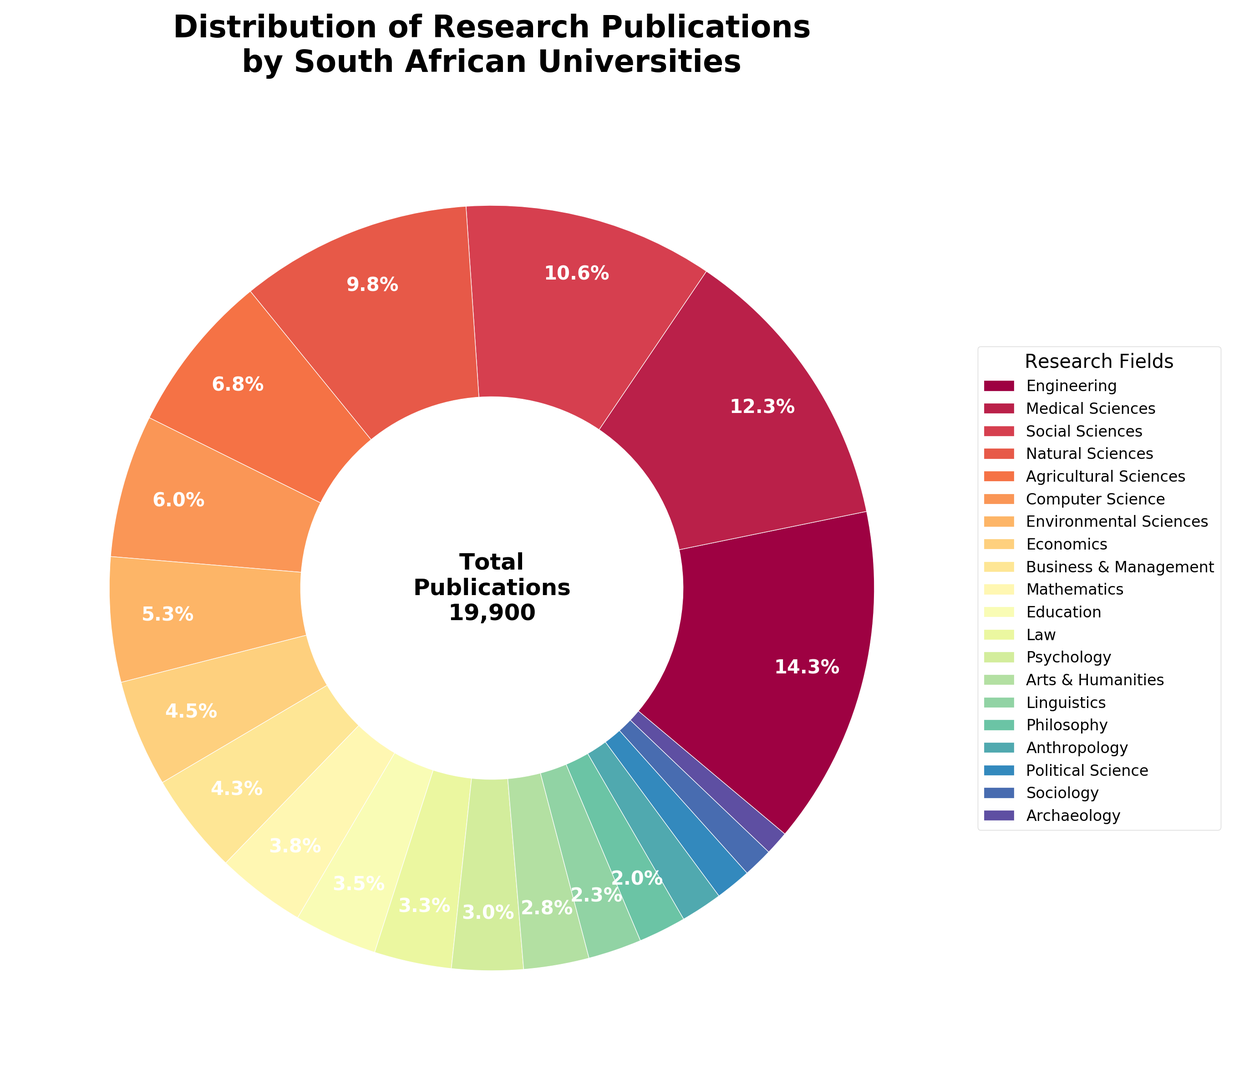Which field has the highest number of publications? To determine the field with the highest number of publications, observe the largest segment in the ring chart.
Answer: Engineering Which field has the lowest number of publications? To identify the field with the fewest publications, look for the smallest segment in the ring chart.
Answer: Archaeology How many fields have more than 10% of the total publications? Excluding fields that contribute less than 10%, identify only the segments labeled with percentages. Add these fields up.
Answer: 1 Which two fields combined have the highest number of publications? Identify the two largest segments in the chart. The two largest fields are likely to be the combination with the highest publications.
Answer: Engineering and Medical Sciences Is the number of publications in Medical Sciences more than twice those in Computer Science? Compare the sizes of the segments. Medical Sciences and Computer Science are represented by their respective sizes; visually estimate if the former is more than twice the latter.
Answer: Yes What percentage of the total publications is contributed by Engineering and Medical Sciences together? Add the percentages of the segments for Engineering and Medical Sciences.
Answer: 30.5% Are there more publications in Social Sciences or Natural Sciences? Compare the segments representing Social Sciences and Natural Sciences. Identify which segment is larger.
Answer: Social Sciences Is the sum of publications in Agricultural Sciences and Environmental Sciences more than Business & Management? Calculate the combined percentage/size of segments for Agricultural Sciences and Environmental Sciences and compare with Business & Management segment.
Answer: Yes What is the approximate combined publication percentage for Social Sciences, Natural Sciences, and Medical Sciences? Sum up the percentages for Social Sciences, Natural Sciences, and Medical Sciences based on their segment sizes.
Answer: 38.0% How does the publication count in Mathematics compare to that in Education? Compare the segments for Mathematics and Education to identify their relative sizes.
Answer: Mathematics has fewer publications than Education 